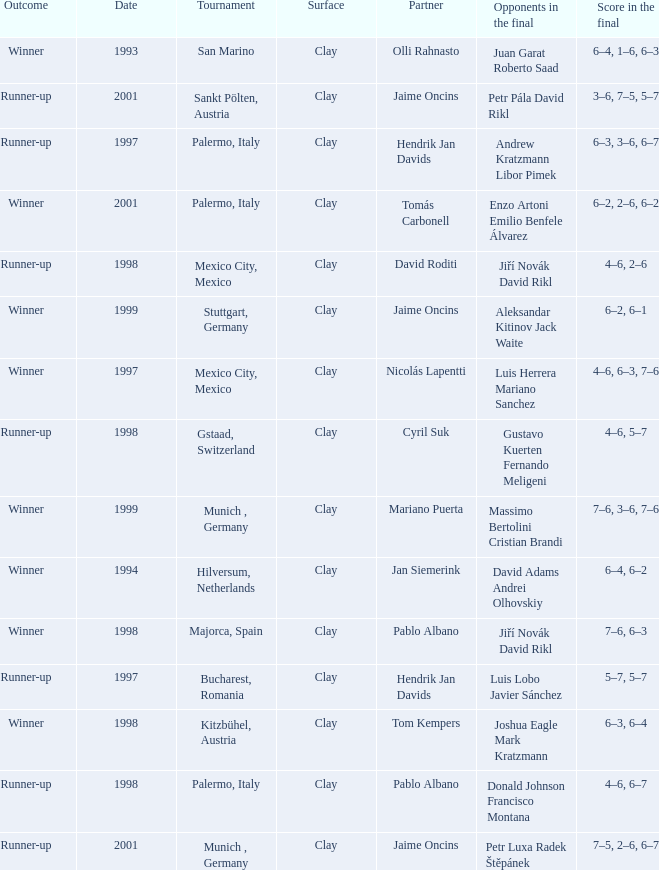Who are the Opponents in the final prior to 1998 in the Bucharest, Romania Tournament? Luis Lobo Javier Sánchez. 